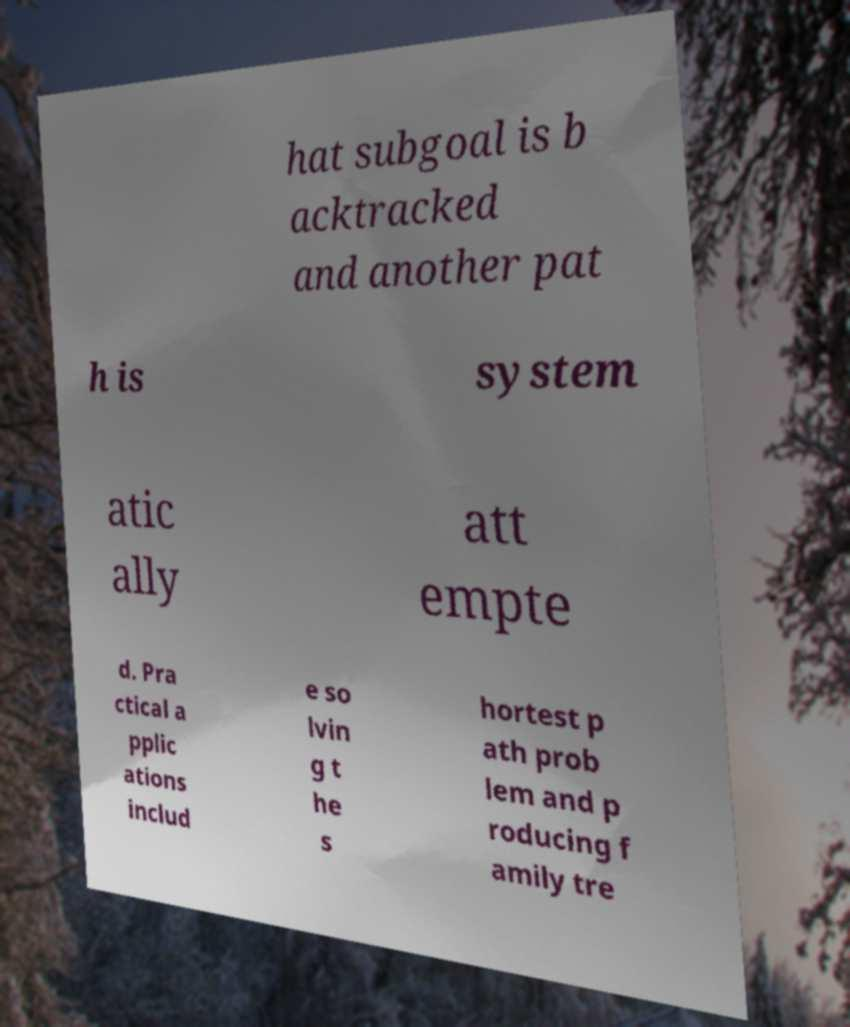Could you assist in decoding the text presented in this image and type it out clearly? hat subgoal is b acktracked and another pat h is system atic ally att empte d. Pra ctical a pplic ations includ e so lvin g t he s hortest p ath prob lem and p roducing f amily tre 